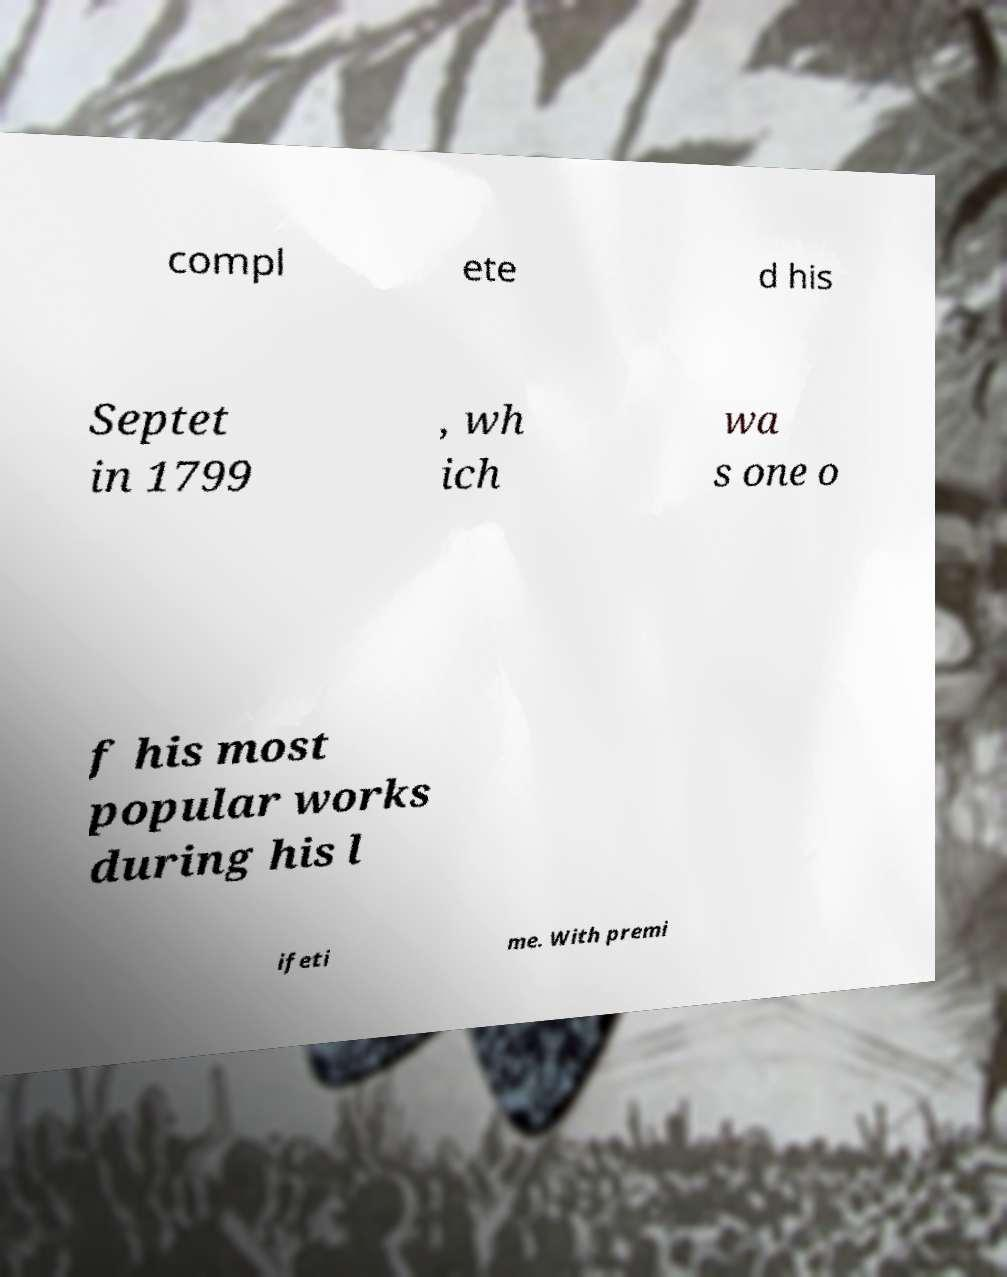What messages or text are displayed in this image? I need them in a readable, typed format. compl ete d his Septet in 1799 , wh ich wa s one o f his most popular works during his l ifeti me. With premi 